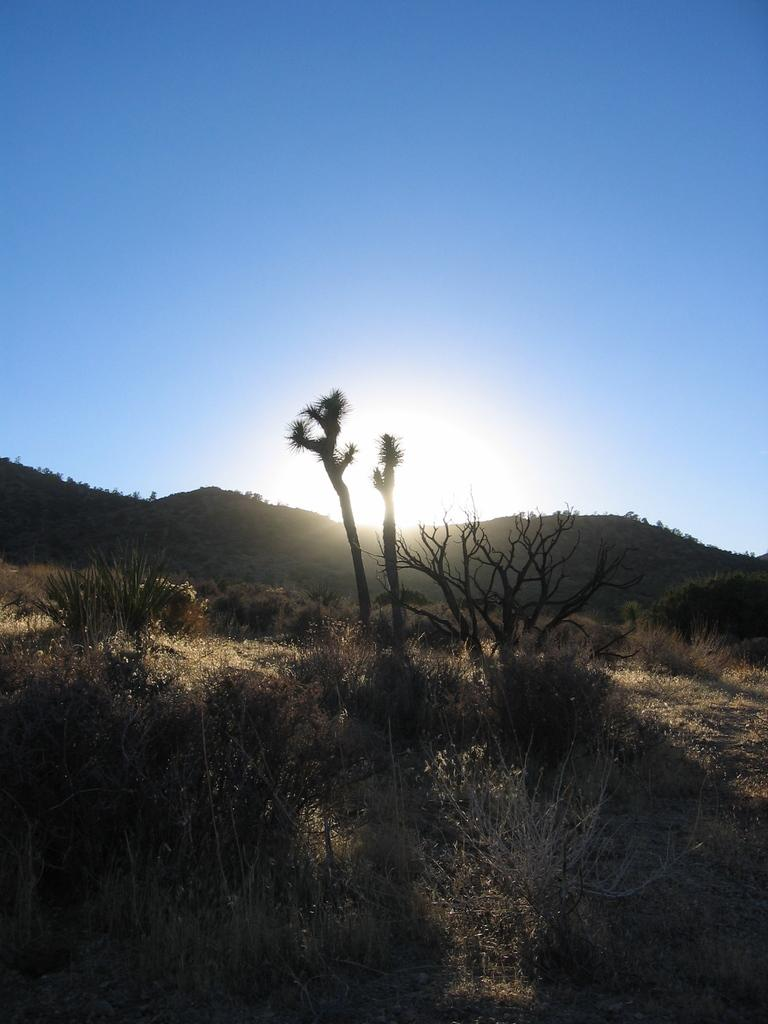What type of vegetation is present in the image? There are many trees, plants, and grass in the image. What can be seen in the background of the image? There are mountains and the sun visible in the background of the image. What is visible at the top of the image? The sky is visible at the top of the image. How many pencils can be seen lying on the grass in the image? There are no pencils present in the image. Are there any girls visible in the image? There is no mention of girls in the provided facts, and therefore we cannot determine if any are present in the image. 